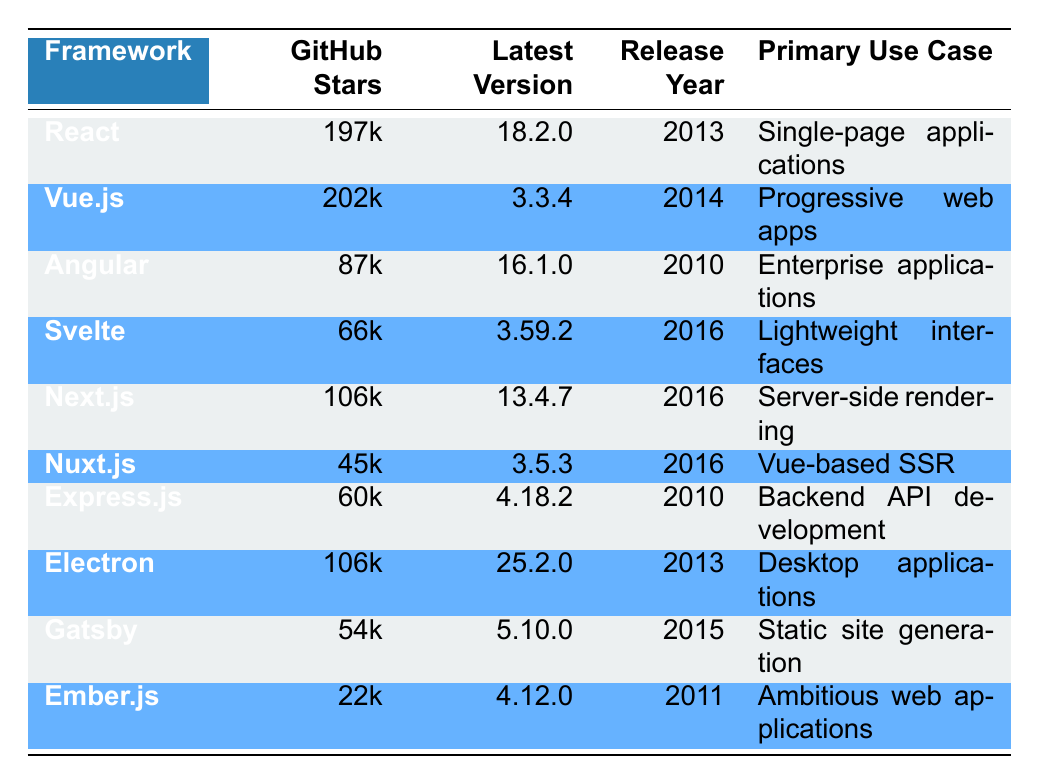What is the GitHub stars count for Vue.js? The table shows that Vue.js has 202k GitHub stars listed in the second column under GitHub Stars.
Answer: 202k Which framework has the lowest GitHub stars? By observing the GitHub Stars column, Ember.js has 22k, which is less than any other framework listed.
Answer: Ember.js Is Angular released after React? React was released in 2013 while Angular was released in 2010, making Angular older than React. Therefore, the statement is false.
Answer: No What are the primary use cases of both Next.js and Nuxt.js? Next.js is used for server-side rendering, while Nuxt.js is used for Vue-based server-side rendering, as shown in the Primary Use Case column.
Answer: Server-side rendering and Vue-based SSR How many frameworks have GitHub stars greater than 100k? React (197k), Vue.js (202k), Next.js (106k), and Electron (106k) have GitHub stars greater than 100k. This totals four frameworks.
Answer: 4 What is the average GitHub stars count of all frameworks listed? Adding the stars: (197 + 202 + 87 + 66 + 106 + 45 + 60 + 106 + 54 + 22) = 1,021 and dividing by 10 (number of frameworks) gives an average of 102.1k stars.
Answer: 102.1k Is Electron more popular than Svelte based on GitHub stars? Electron has 106k stars, while Svelte has 66k stars, indicating that Electron is more popular than Svelte. This statement is true.
Answer: Yes Which framework was released in 2016 and has the highest GitHub stars? Among the frameworks released in 2016, Next.js has 106k stars, while Svelte has 66k stars, and Nuxt.js has 45k stars. Next.js has the highest stars of the ones released in that year.
Answer: Next.js What is the difference in GitHub stars between Angular and Ember.js? Angular has 87k stars and Ember.js has 22k stars. The difference is 87k - 22k = 65k stars.
Answer: 65k 